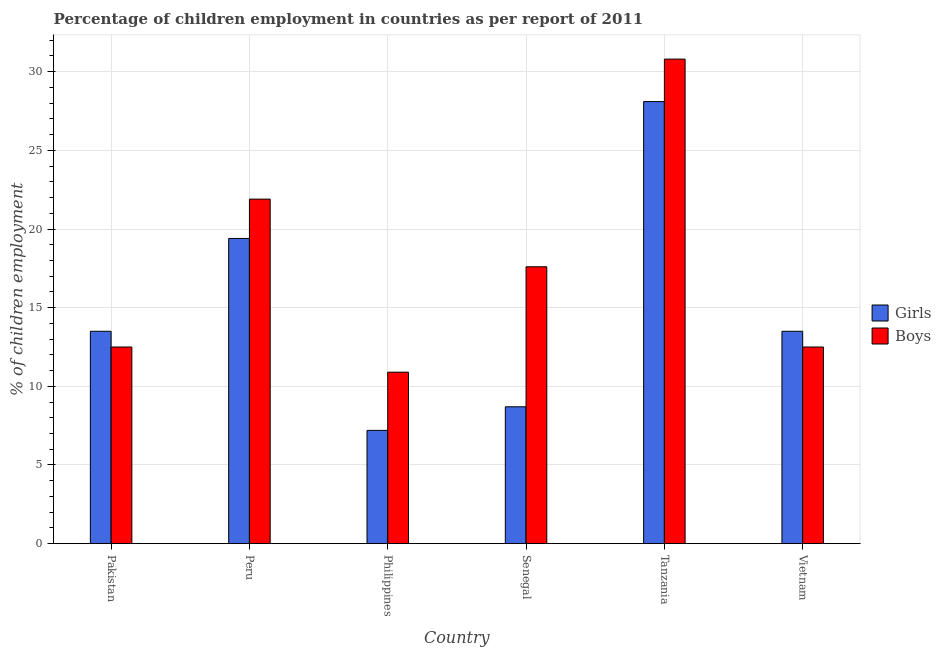How many different coloured bars are there?
Your answer should be very brief. 2. Are the number of bars per tick equal to the number of legend labels?
Keep it short and to the point. Yes. Are the number of bars on each tick of the X-axis equal?
Offer a terse response. Yes. How many bars are there on the 1st tick from the right?
Provide a succinct answer. 2. What is the percentage of employed boys in Tanzania?
Your answer should be very brief. 30.8. Across all countries, what is the maximum percentage of employed girls?
Provide a short and direct response. 28.1. In which country was the percentage of employed girls maximum?
Offer a very short reply. Tanzania. In which country was the percentage of employed girls minimum?
Make the answer very short. Philippines. What is the total percentage of employed boys in the graph?
Provide a succinct answer. 106.2. What is the difference between the percentage of employed boys in Pakistan and that in Vietnam?
Keep it short and to the point. 0. In how many countries, is the percentage of employed girls greater than 13 %?
Make the answer very short. 4. Is the percentage of employed boys in Peru less than that in Vietnam?
Your response must be concise. No. Is the difference between the percentage of employed boys in Peru and Vietnam greater than the difference between the percentage of employed girls in Peru and Vietnam?
Make the answer very short. Yes. What is the difference between the highest and the second highest percentage of employed girls?
Make the answer very short. 8.7. What is the difference between the highest and the lowest percentage of employed girls?
Keep it short and to the point. 20.9. Is the sum of the percentage of employed girls in Philippines and Tanzania greater than the maximum percentage of employed boys across all countries?
Offer a very short reply. Yes. What does the 1st bar from the left in Pakistan represents?
Keep it short and to the point. Girls. What does the 2nd bar from the right in Senegal represents?
Make the answer very short. Girls. How many bars are there?
Make the answer very short. 12. Are all the bars in the graph horizontal?
Your answer should be compact. No. What is the difference between two consecutive major ticks on the Y-axis?
Provide a succinct answer. 5. Where does the legend appear in the graph?
Offer a terse response. Center right. How are the legend labels stacked?
Provide a short and direct response. Vertical. What is the title of the graph?
Offer a very short reply. Percentage of children employment in countries as per report of 2011. Does "Manufacturing industries and construction" appear as one of the legend labels in the graph?
Make the answer very short. No. What is the label or title of the Y-axis?
Ensure brevity in your answer.  % of children employment. What is the % of children employment of Girls in Peru?
Provide a short and direct response. 19.4. What is the % of children employment in Boys in Peru?
Provide a succinct answer. 21.9. What is the % of children employment in Girls in Philippines?
Your response must be concise. 7.2. What is the % of children employment of Boys in Philippines?
Your answer should be compact. 10.9. What is the % of children employment of Girls in Senegal?
Offer a very short reply. 8.7. What is the % of children employment of Boys in Senegal?
Offer a very short reply. 17.6. What is the % of children employment in Girls in Tanzania?
Make the answer very short. 28.1. What is the % of children employment in Boys in Tanzania?
Make the answer very short. 30.8. Across all countries, what is the maximum % of children employment in Girls?
Offer a very short reply. 28.1. Across all countries, what is the maximum % of children employment of Boys?
Your response must be concise. 30.8. Across all countries, what is the minimum % of children employment of Girls?
Offer a very short reply. 7.2. What is the total % of children employment of Girls in the graph?
Keep it short and to the point. 90.4. What is the total % of children employment in Boys in the graph?
Ensure brevity in your answer.  106.2. What is the difference between the % of children employment in Girls in Pakistan and that in Peru?
Provide a succinct answer. -5.9. What is the difference between the % of children employment of Girls in Pakistan and that in Tanzania?
Make the answer very short. -14.6. What is the difference between the % of children employment in Boys in Pakistan and that in Tanzania?
Your answer should be compact. -18.3. What is the difference between the % of children employment of Girls in Pakistan and that in Vietnam?
Ensure brevity in your answer.  0. What is the difference between the % of children employment of Girls in Peru and that in Philippines?
Your answer should be compact. 12.2. What is the difference between the % of children employment of Boys in Peru and that in Philippines?
Your answer should be very brief. 11. What is the difference between the % of children employment in Girls in Peru and that in Senegal?
Make the answer very short. 10.7. What is the difference between the % of children employment of Boys in Peru and that in Senegal?
Keep it short and to the point. 4.3. What is the difference between the % of children employment in Boys in Peru and that in Vietnam?
Your response must be concise. 9.4. What is the difference between the % of children employment of Boys in Philippines and that in Senegal?
Your response must be concise. -6.7. What is the difference between the % of children employment of Girls in Philippines and that in Tanzania?
Your response must be concise. -20.9. What is the difference between the % of children employment of Boys in Philippines and that in Tanzania?
Your answer should be very brief. -19.9. What is the difference between the % of children employment of Boys in Philippines and that in Vietnam?
Provide a short and direct response. -1.6. What is the difference between the % of children employment of Girls in Senegal and that in Tanzania?
Your answer should be very brief. -19.4. What is the difference between the % of children employment in Boys in Senegal and that in Vietnam?
Make the answer very short. 5.1. What is the difference between the % of children employment in Girls in Tanzania and that in Vietnam?
Give a very brief answer. 14.6. What is the difference between the % of children employment of Girls in Pakistan and the % of children employment of Boys in Tanzania?
Offer a very short reply. -17.3. What is the difference between the % of children employment of Girls in Peru and the % of children employment of Boys in Tanzania?
Your answer should be compact. -11.4. What is the difference between the % of children employment in Girls in Philippines and the % of children employment in Boys in Tanzania?
Give a very brief answer. -23.6. What is the difference between the % of children employment of Girls in Philippines and the % of children employment of Boys in Vietnam?
Your response must be concise. -5.3. What is the difference between the % of children employment in Girls in Senegal and the % of children employment in Boys in Tanzania?
Offer a terse response. -22.1. What is the difference between the % of children employment of Girls in Senegal and the % of children employment of Boys in Vietnam?
Your answer should be very brief. -3.8. What is the average % of children employment of Girls per country?
Your answer should be very brief. 15.07. What is the average % of children employment of Boys per country?
Keep it short and to the point. 17.7. What is the difference between the % of children employment of Girls and % of children employment of Boys in Pakistan?
Your answer should be compact. 1. What is the difference between the % of children employment in Girls and % of children employment in Boys in Peru?
Provide a succinct answer. -2.5. What is the difference between the % of children employment of Girls and % of children employment of Boys in Philippines?
Offer a very short reply. -3.7. What is the difference between the % of children employment in Girls and % of children employment in Boys in Senegal?
Provide a succinct answer. -8.9. What is the difference between the % of children employment of Girls and % of children employment of Boys in Tanzania?
Ensure brevity in your answer.  -2.7. What is the difference between the % of children employment of Girls and % of children employment of Boys in Vietnam?
Make the answer very short. 1. What is the ratio of the % of children employment of Girls in Pakistan to that in Peru?
Make the answer very short. 0.7. What is the ratio of the % of children employment in Boys in Pakistan to that in Peru?
Provide a succinct answer. 0.57. What is the ratio of the % of children employment of Girls in Pakistan to that in Philippines?
Your response must be concise. 1.88. What is the ratio of the % of children employment of Boys in Pakistan to that in Philippines?
Keep it short and to the point. 1.15. What is the ratio of the % of children employment in Girls in Pakistan to that in Senegal?
Offer a terse response. 1.55. What is the ratio of the % of children employment in Boys in Pakistan to that in Senegal?
Give a very brief answer. 0.71. What is the ratio of the % of children employment of Girls in Pakistan to that in Tanzania?
Give a very brief answer. 0.48. What is the ratio of the % of children employment in Boys in Pakistan to that in Tanzania?
Keep it short and to the point. 0.41. What is the ratio of the % of children employment in Girls in Pakistan to that in Vietnam?
Your response must be concise. 1. What is the ratio of the % of children employment of Girls in Peru to that in Philippines?
Offer a very short reply. 2.69. What is the ratio of the % of children employment of Boys in Peru to that in Philippines?
Provide a short and direct response. 2.01. What is the ratio of the % of children employment in Girls in Peru to that in Senegal?
Offer a very short reply. 2.23. What is the ratio of the % of children employment in Boys in Peru to that in Senegal?
Your answer should be very brief. 1.24. What is the ratio of the % of children employment in Girls in Peru to that in Tanzania?
Your answer should be very brief. 0.69. What is the ratio of the % of children employment in Boys in Peru to that in Tanzania?
Your response must be concise. 0.71. What is the ratio of the % of children employment of Girls in Peru to that in Vietnam?
Make the answer very short. 1.44. What is the ratio of the % of children employment of Boys in Peru to that in Vietnam?
Make the answer very short. 1.75. What is the ratio of the % of children employment in Girls in Philippines to that in Senegal?
Provide a short and direct response. 0.83. What is the ratio of the % of children employment in Boys in Philippines to that in Senegal?
Give a very brief answer. 0.62. What is the ratio of the % of children employment in Girls in Philippines to that in Tanzania?
Your answer should be compact. 0.26. What is the ratio of the % of children employment in Boys in Philippines to that in Tanzania?
Give a very brief answer. 0.35. What is the ratio of the % of children employment of Girls in Philippines to that in Vietnam?
Keep it short and to the point. 0.53. What is the ratio of the % of children employment in Boys in Philippines to that in Vietnam?
Give a very brief answer. 0.87. What is the ratio of the % of children employment in Girls in Senegal to that in Tanzania?
Give a very brief answer. 0.31. What is the ratio of the % of children employment of Boys in Senegal to that in Tanzania?
Give a very brief answer. 0.57. What is the ratio of the % of children employment of Girls in Senegal to that in Vietnam?
Provide a short and direct response. 0.64. What is the ratio of the % of children employment in Boys in Senegal to that in Vietnam?
Your answer should be very brief. 1.41. What is the ratio of the % of children employment of Girls in Tanzania to that in Vietnam?
Keep it short and to the point. 2.08. What is the ratio of the % of children employment in Boys in Tanzania to that in Vietnam?
Provide a short and direct response. 2.46. What is the difference between the highest and the second highest % of children employment of Girls?
Give a very brief answer. 8.7. What is the difference between the highest and the second highest % of children employment of Boys?
Offer a terse response. 8.9. What is the difference between the highest and the lowest % of children employment of Girls?
Provide a short and direct response. 20.9. What is the difference between the highest and the lowest % of children employment in Boys?
Provide a succinct answer. 19.9. 